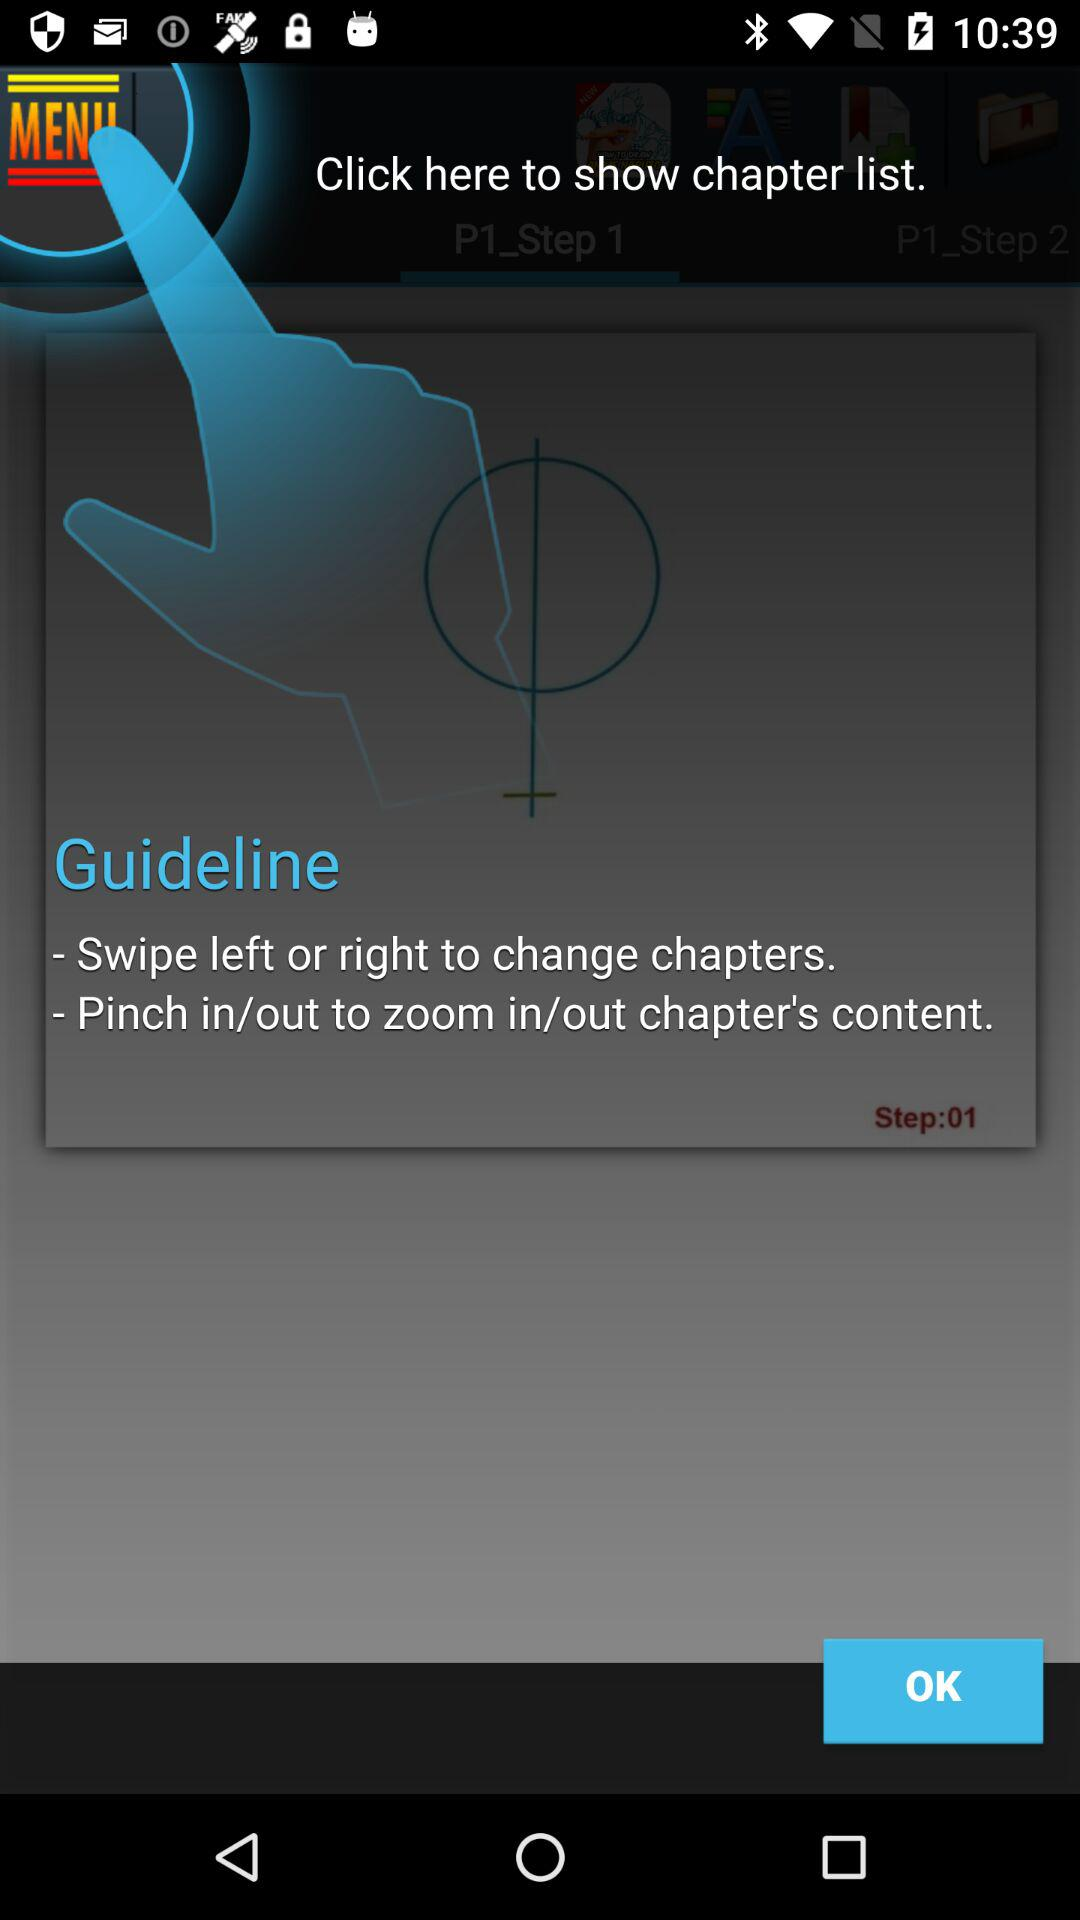How many steps are there?
Answer the question using a single word or phrase. 2 